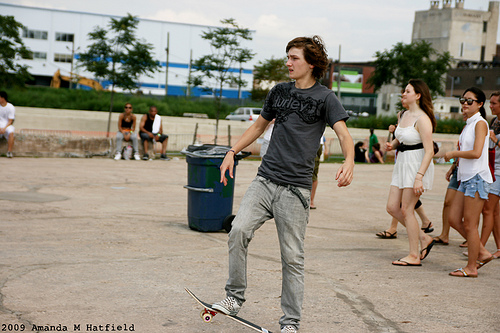Extract all visible text content from this image. TURLEY Hatfield Amanada 2009 